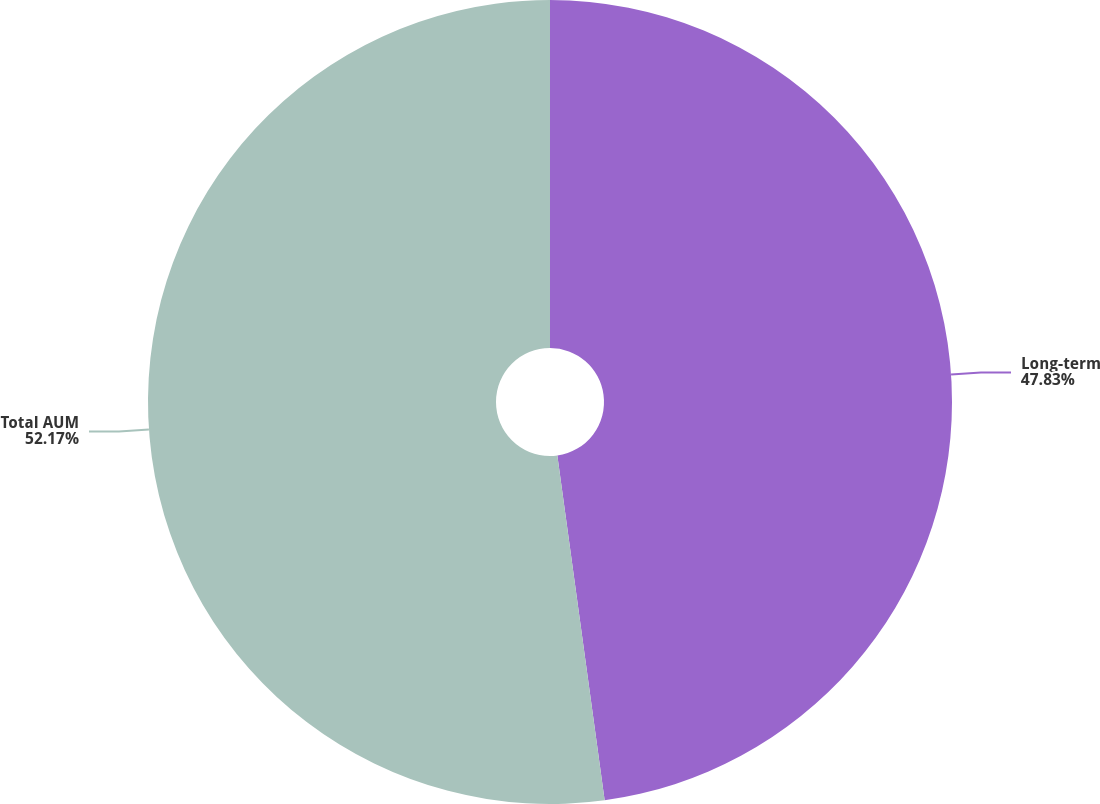<chart> <loc_0><loc_0><loc_500><loc_500><pie_chart><fcel>Long-term<fcel>Total AUM<nl><fcel>47.83%<fcel>52.17%<nl></chart> 